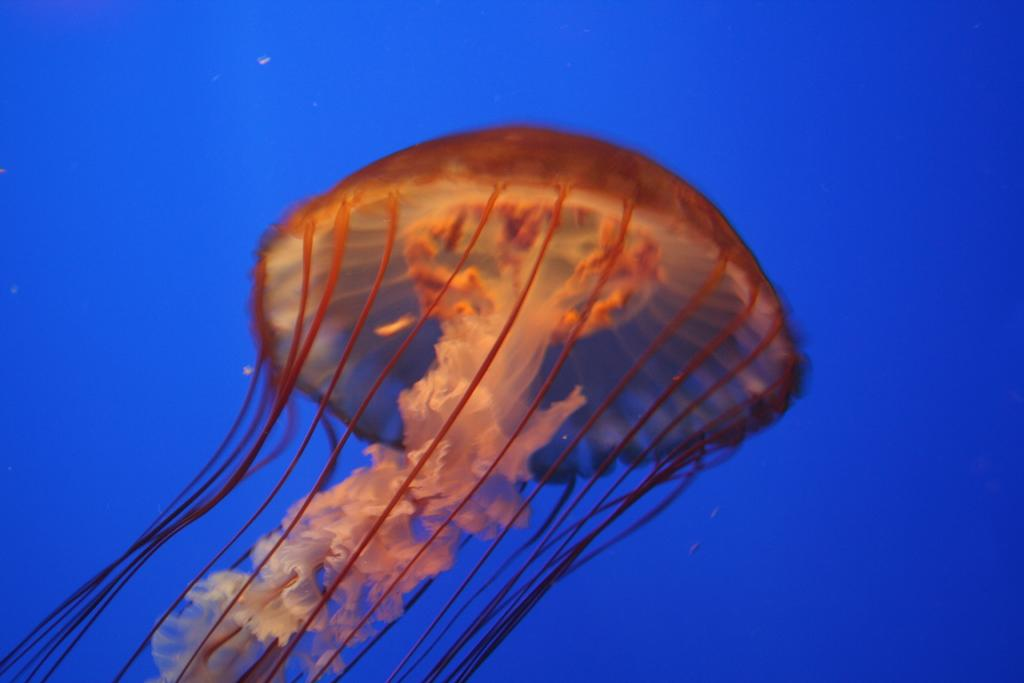What type of sea creature is in the image? There is a jellyfish in the image. Where is the jellyfish located? The jellyfish is inside the water. What color is the background of the image? The background of the image is blue. What type of guitar can be seen being played in the image? There is no guitar present in the image; it features a jellyfish inside the water with a blue background. 